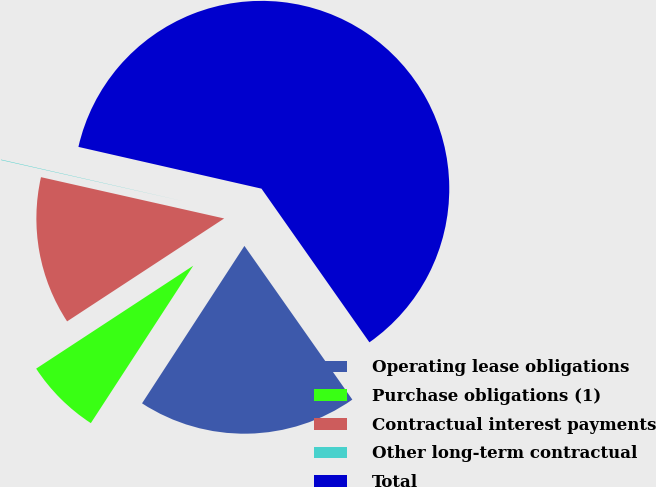Convert chart to OTSL. <chart><loc_0><loc_0><loc_500><loc_500><pie_chart><fcel>Operating lease obligations<fcel>Purchase obligations (1)<fcel>Contractual interest payments<fcel>Other long-term contractual<fcel>Total<nl><fcel>18.92%<fcel>6.59%<fcel>12.76%<fcel>0.04%<fcel>61.68%<nl></chart> 